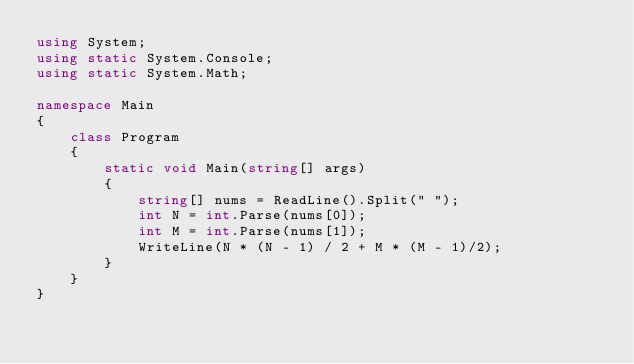<code> <loc_0><loc_0><loc_500><loc_500><_C#_>using System;
using static System.Console;
using static System.Math;

namespace Main
{
    class Program
    {
        static void Main(string[] args)
        {
            string[] nums = ReadLine().Split(" ");
            int N = int.Parse(nums[0]);
            int M = int.Parse(nums[1]);
            WriteLine(N * (N - 1) / 2 + M * (M - 1)/2);
        }
    }
}</code> 